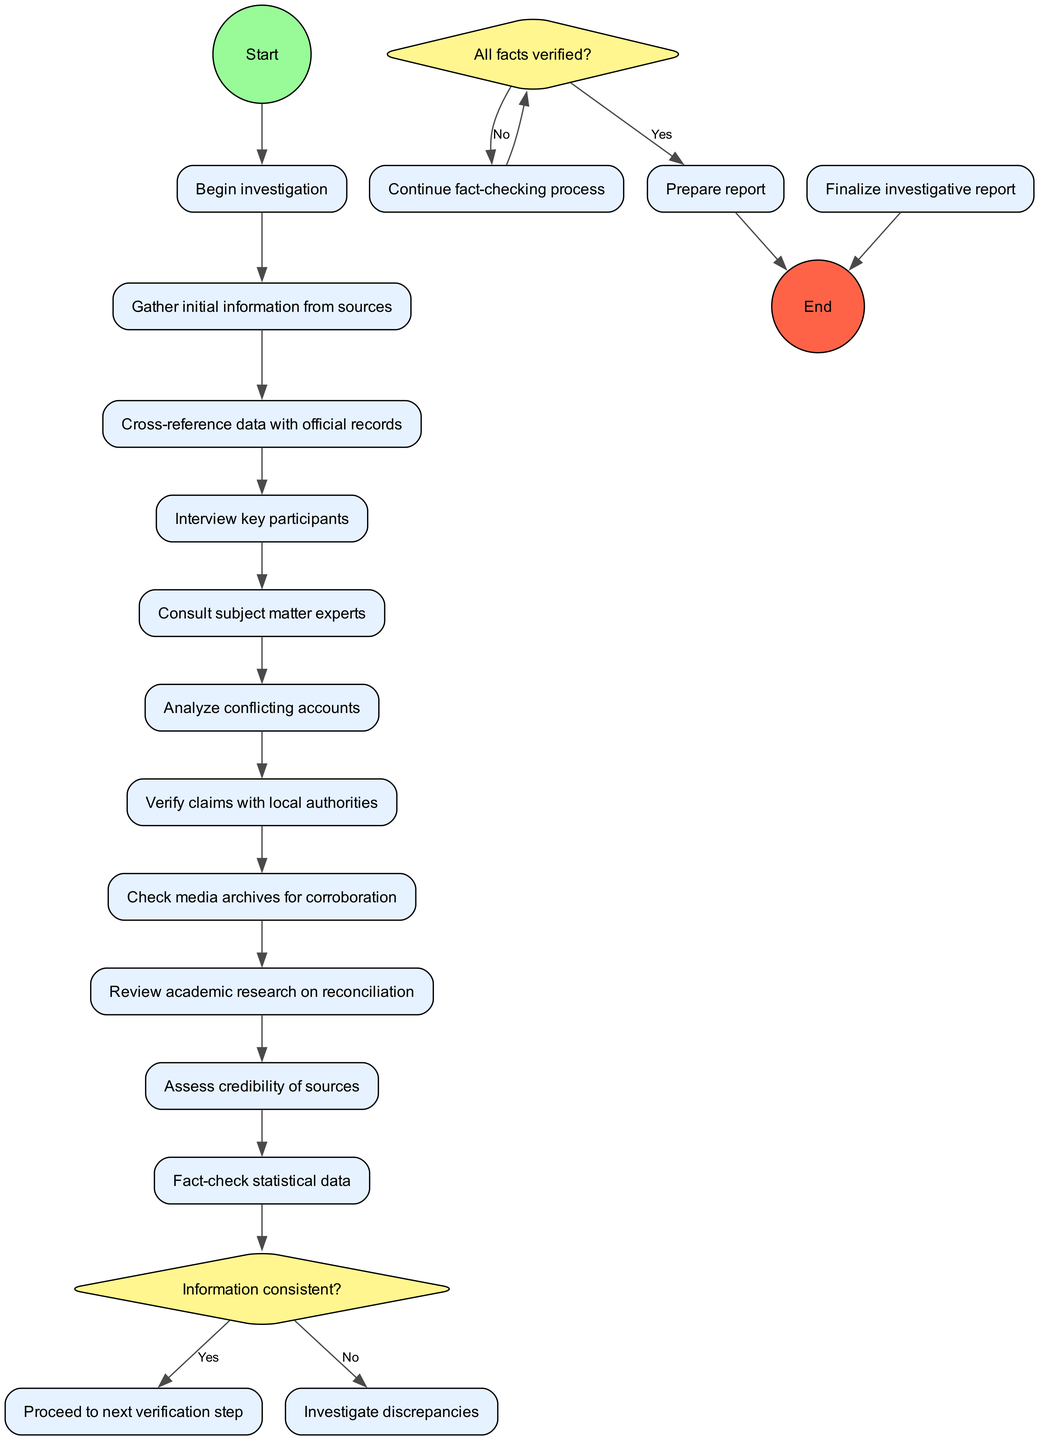What is the first activity in the diagram? The diagram starts with the node labeled "Gather initial information from sources." This is directly connected to the start node.
Answer: Gather initial information from sources How many total activities are present in the diagram? There are 10 activities listed in the diagram that represent the steps taken during the investigation process.
Answer: 10 What action follows after interviewing key participants? The next action after "Interview key participants" is "Consult subject matter experts," as indicated by the edges connecting these nodes.
Answer: Consult subject matter experts What happens if the information is consistent? If the information is consistent, the flow proceeds to the next verification step, as indicated by the "Yes" edge from that decision node.
Answer: Proceed to next verification step How many decision points are there in the diagram? There are 2 decision nodes present in the diagram that evaluate the consistency and verification of information.
Answer: 2 What is the final step in the action flow? The final step in the action flow is represented by the node labeled "Prepare report," which connects to the end node.
Answer: Prepare report If not all facts are verified, what is the next action taken? If not all facts are verified, the process will continue the fact-checking process as indicated by the "No" edge from the decision node.
Answer: Continue fact-checking process How is the credibility of sources assessed? The credibility of sources is assessed as one of the activities listed in the diagram, specifically mentioned in the activities sequence.
Answer: Assess credibility of sources What type of diagram is this? This is an Activity Diagram, which is specific to representing workflows and processes in a sequential manner.
Answer: Activity Diagram 